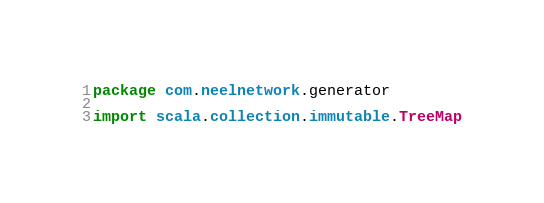<code> <loc_0><loc_0><loc_500><loc_500><_Scala_>package com.neelnetwork.generator

import scala.collection.immutable.TreeMap
</code> 